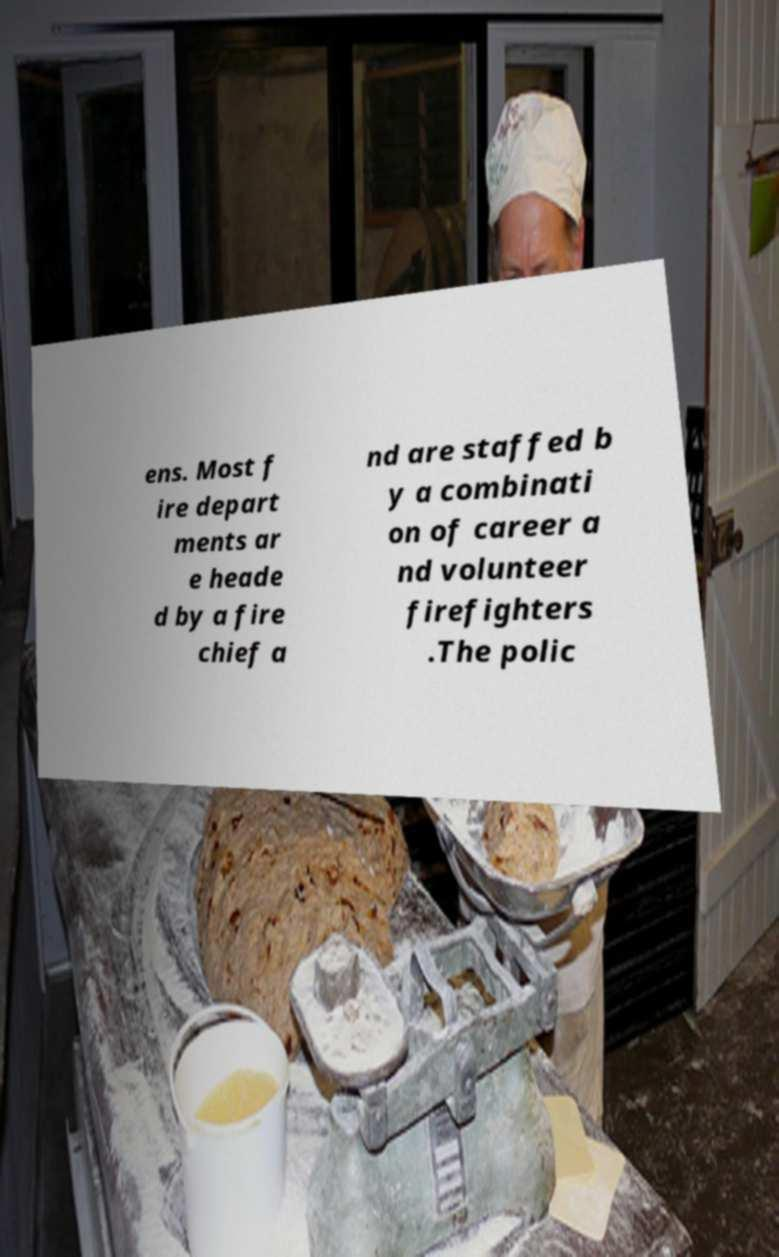What messages or text are displayed in this image? I need them in a readable, typed format. ens. Most f ire depart ments ar e heade d by a fire chief a nd are staffed b y a combinati on of career a nd volunteer firefighters .The polic 